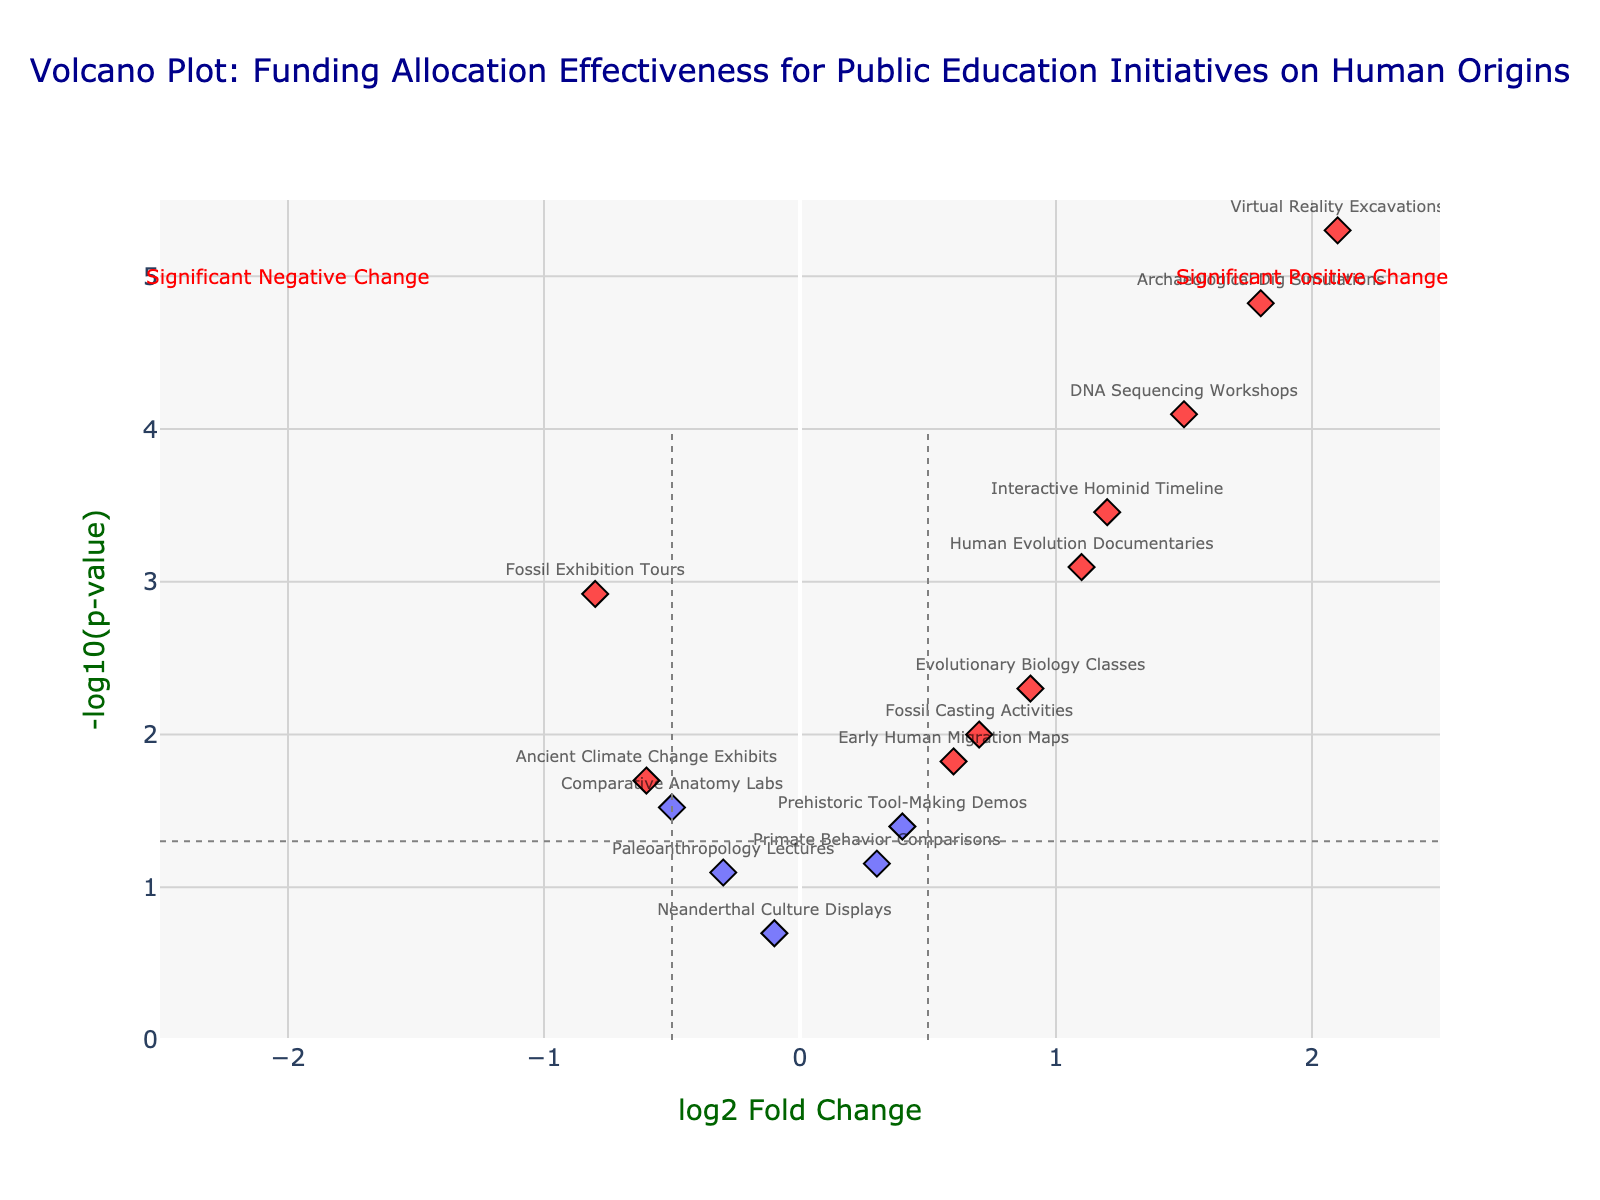What is the title of the plot? The title of the plot is prominently displayed at the top center of the figure. Reading this text gives us the title of the plot.
Answer: Volcano Plot: Funding Allocation Effectiveness for Public Education Initiatives on Human Origins Which initiative has the highest log2 fold change? By looking at the x-axis (log2 Fold Change) and identifying the data point farthest to the right, we can see which initiative has the highest value.
Answer: Virtual Reality Excavations Which initiative has the smallest p-value? By looking at the y-axis (-log10(p-value)) and identifying the data point highest up, we see which initiative has the smallest p-value.
Answer: Virtual Reality Excavations How many initiatives show a significant positive change (log2 Fold Change > 0.5 and p-value < 0.05)? The significant data points are colored differently. Count the number of red points to the right of 0.5 on the x-axis and below -log10(0.05) on the y-axis.
Answer: 7 Which initiatives show a significant negative change (log2 Fold Change < -0.5 and p-value < 0.05)? Look for red points to the left of -0.5 on the x-axis and below -log10(0.05) on the y-axis. These points will correspond to significant negative changes.
Answer: Fossil Exhibition Tours, Ancient Climate Change Exhibits What does the vertical line at log2 Fold Change = 0.5 represent? This vertical line separates initiatives with higher positive fold changes. Anything beyond this line to the right indicates a log2 Fold Change greater than 0.5.
Answer: Fold change threshold for significant positive changes How do DNA Sequencing Workshops and Interactive Hominid Timeline differ in terms of their log2 fold change and p-value? Comparing their positions on the plot, we find DNA Sequencing Workshops has a log2 Fold Change of 1.5 and p-value of 0.00008, while Interactive Hominid Timeline has a log2 Fold Change of 1.2 and p-value of 0.00035. DNA Sequencing Workshops have both a higher fold change and a smaller p-value.
Answer: DNA Sequencing Workshops have higher log2 Fold Change and lower p-value What is the -log10(p-value) for Human Evolution Documentaries? Find the data point for Human Evolution Documentaries and look at its position on the y-axis. The y-axis shows the -log10(p-value).
Answer: 3.0969 How many initiatives have a log2 fold change approximately equal to 0? Looking around the x-axis value of 0, identify the number of points that are close to this value.
Answer: 1 What is the significance threshold for p-value in this plot? The significance threshold is marked by a dashed horizontal line on the plot. This line corresponds to -log10(0.05).
Answer: 0.05 